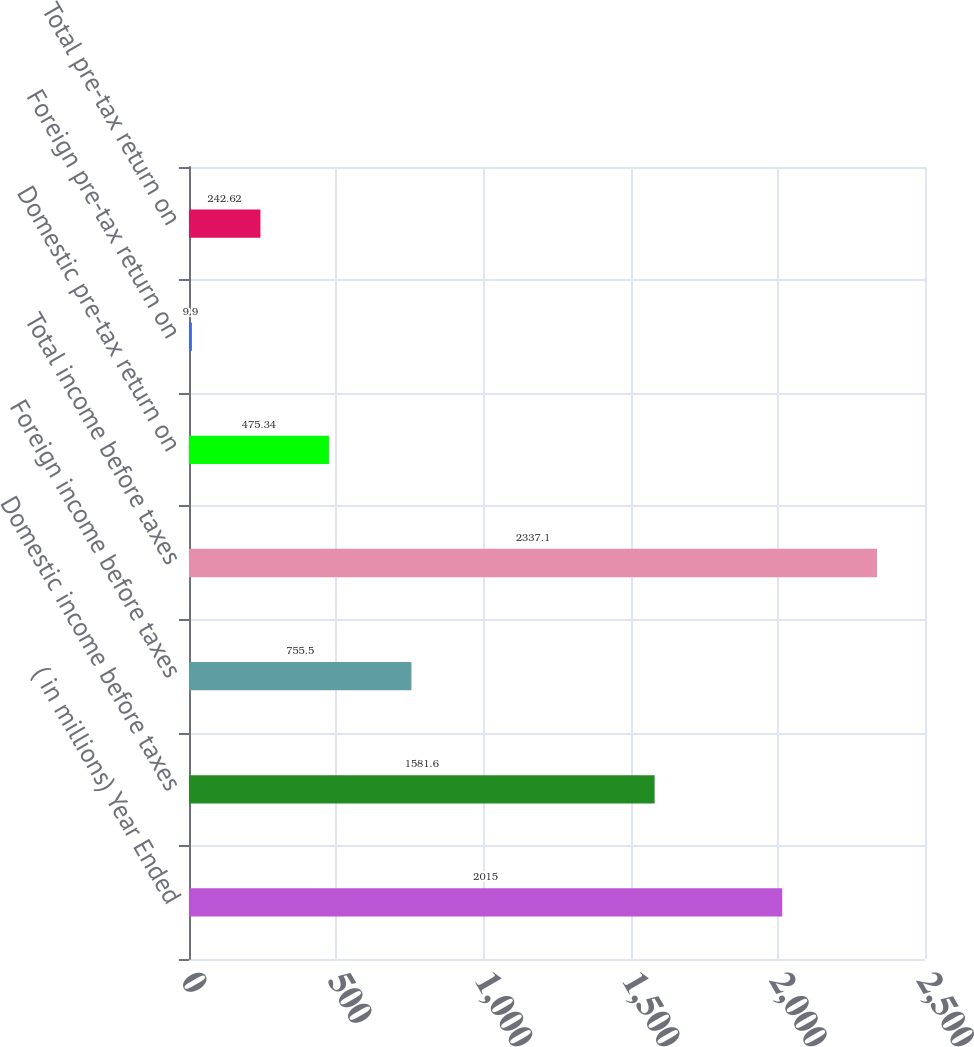<chart> <loc_0><loc_0><loc_500><loc_500><bar_chart><fcel>( in millions) Year Ended<fcel>Domestic income before taxes<fcel>Foreign income before taxes<fcel>Total income before taxes<fcel>Domestic pre-tax return on<fcel>Foreign pre-tax return on<fcel>Total pre-tax return on<nl><fcel>2015<fcel>1581.6<fcel>755.5<fcel>2337.1<fcel>475.34<fcel>9.9<fcel>242.62<nl></chart> 